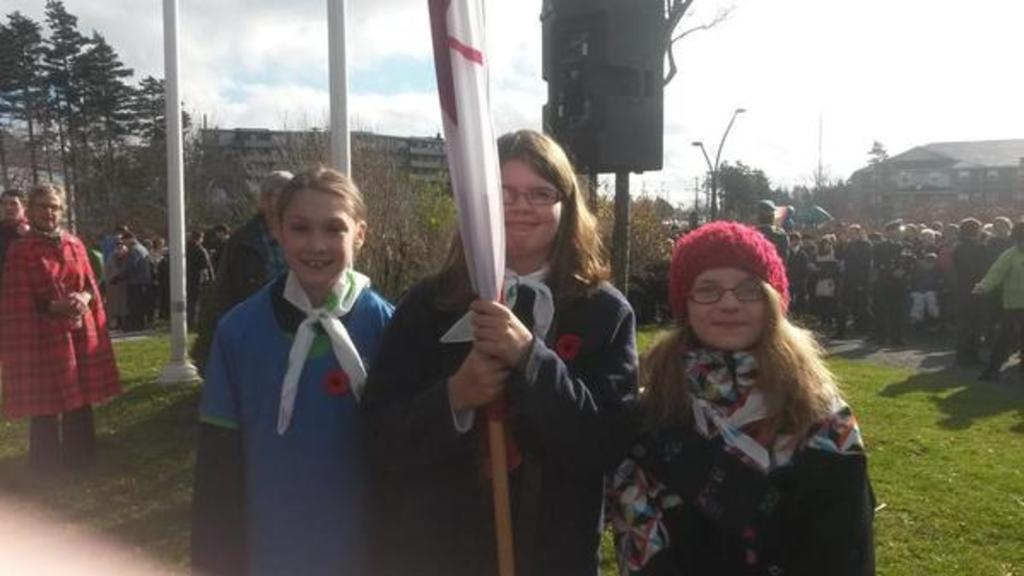How many girls are in the image? There are three girls in the image. What is the facial expression of the girls? The girls are smiling. What can be seen in the image besides the girls? There is a flag, a group of people, trees, buildings, poles, and the sky visible in the image. What is the condition of the sky in the image? The sky is visible in the background of the image, and clouds are present in the sky. Can you see any wounds on the girls in the image? There is no indication of any wounds on the girls in the image. What type of jelly is being used to create the flag in the image? There is no jelly present in the image; it is a flag made of fabric or other materials. 